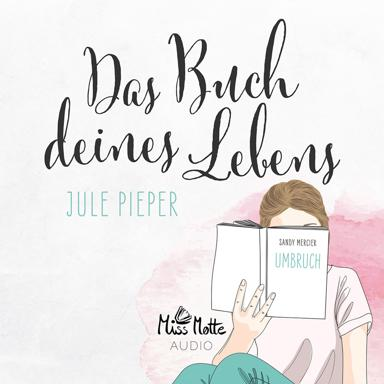Can you describe the girl's posture in the image? The girl is sitting comfortably on the floor, deeply engrossed in reading a book. She appears relaxed and content, with her surroundings softly blurred out, emphasizing a peaceful reading environment. 